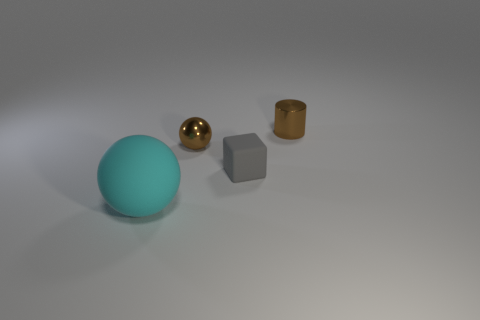Add 3 big gray metal objects. How many objects exist? 7 Subtract all cylinders. How many objects are left? 3 Add 4 large balls. How many large balls are left? 5 Add 4 big green metal cubes. How many big green metal cubes exist? 4 Subtract 0 yellow blocks. How many objects are left? 4 Subtract all small green rubber cylinders. Subtract all matte things. How many objects are left? 2 